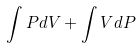Convert formula to latex. <formula><loc_0><loc_0><loc_500><loc_500>\int P d V + \int V d P</formula> 